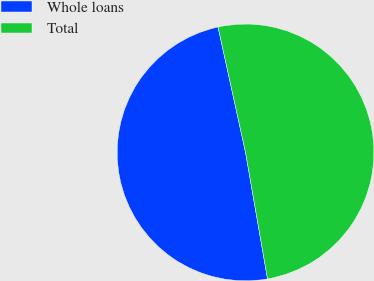Convert chart to OTSL. <chart><loc_0><loc_0><loc_500><loc_500><pie_chart><fcel>Whole loans<fcel>Total<nl><fcel>49.3%<fcel>50.7%<nl></chart> 